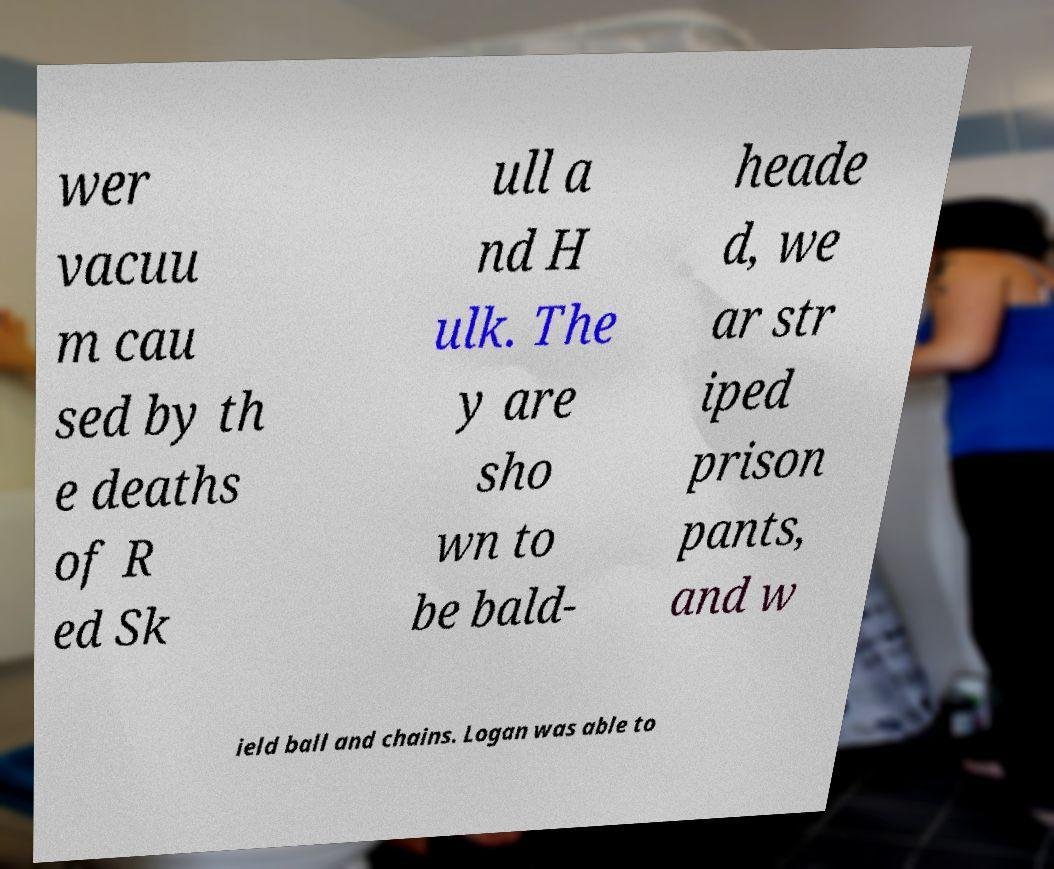What messages or text are displayed in this image? I need them in a readable, typed format. wer vacuu m cau sed by th e deaths of R ed Sk ull a nd H ulk. The y are sho wn to be bald- heade d, we ar str iped prison pants, and w ield ball and chains. Logan was able to 